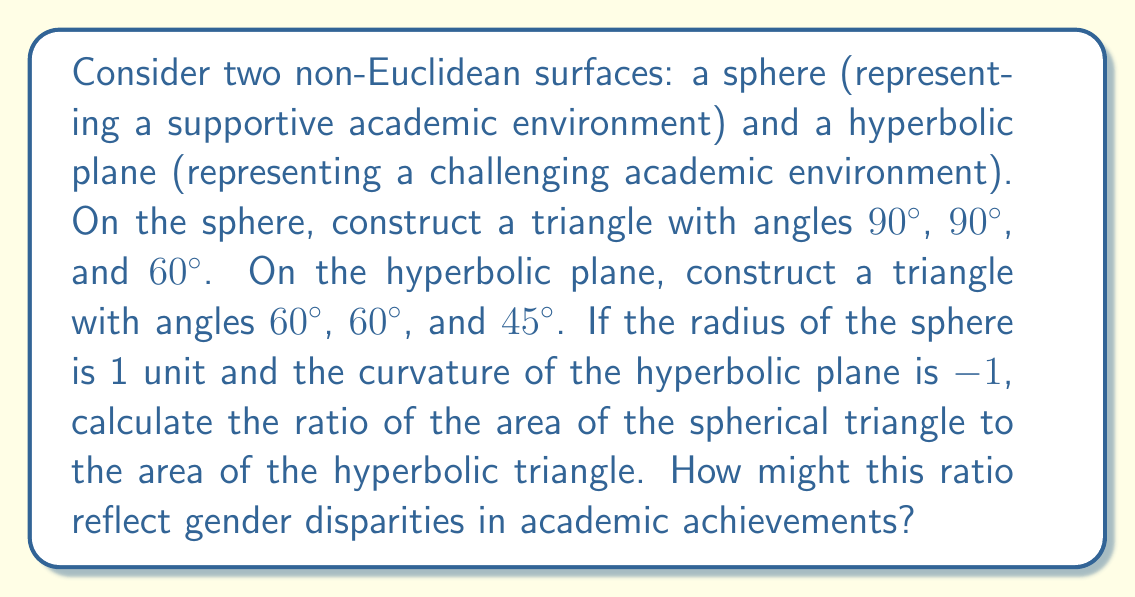Can you answer this question? 1. For the spherical triangle:
   - The area of a spherical triangle is given by the formula: $A = R^2(α + β + γ - π)$
   - Where $R$ is the radius of the sphere, and $α$, $β$, $γ$ are the angles in radians
   - Converting angles to radians: $90° = \frac{\pi}{2}$, $60° = \frac{\pi}{3}$
   - Substituting values: $A_s = 1^2(\frac{\pi}{2} + \frac{\pi}{2} + \frac{\pi}{3} - \pi) = \frac{\pi}{3}$

2. For the hyperbolic triangle:
   - The area of a hyperbolic triangle is given by the formula: $A = \frac{π - (α + β + γ)}{|K|}$
   - Where $K$ is the curvature, and $α$, $β$, $γ$ are the angles in radians
   - Converting angles to radians: $60° = \frac{\pi}{3}$, $45° = \frac{\pi}{4}$
   - Substituting values: $A_h = \frac{\pi - (\frac{\pi}{3} + \frac{\pi}{3} + \frac{\pi}{4})}{|-1|} = \frac{\pi}{12}$

3. Calculate the ratio:
   $\frac{A_s}{A_h} = \frac{\frac{\pi}{3}}{\frac{\pi}{12}} = 4$

This ratio suggests that the "supportive" environment (sphere) provides 4 times more "area" or opportunity for academic achievement compared to the "challenging" environment (hyperbolic plane). In the context of gender disparities, this could represent how supportive academic environments may lead to more equitable outcomes, while challenging or biased environments may disproportionately affect certain groups, potentially exacerbating gender gaps in academic achievements.
Answer: 4 